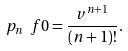Convert formula to latex. <formula><loc_0><loc_0><loc_500><loc_500>\ p _ { n } \ f { 0 } = \frac { v ^ { n + 1 } } { ( n + 1 ) ! } .</formula> 